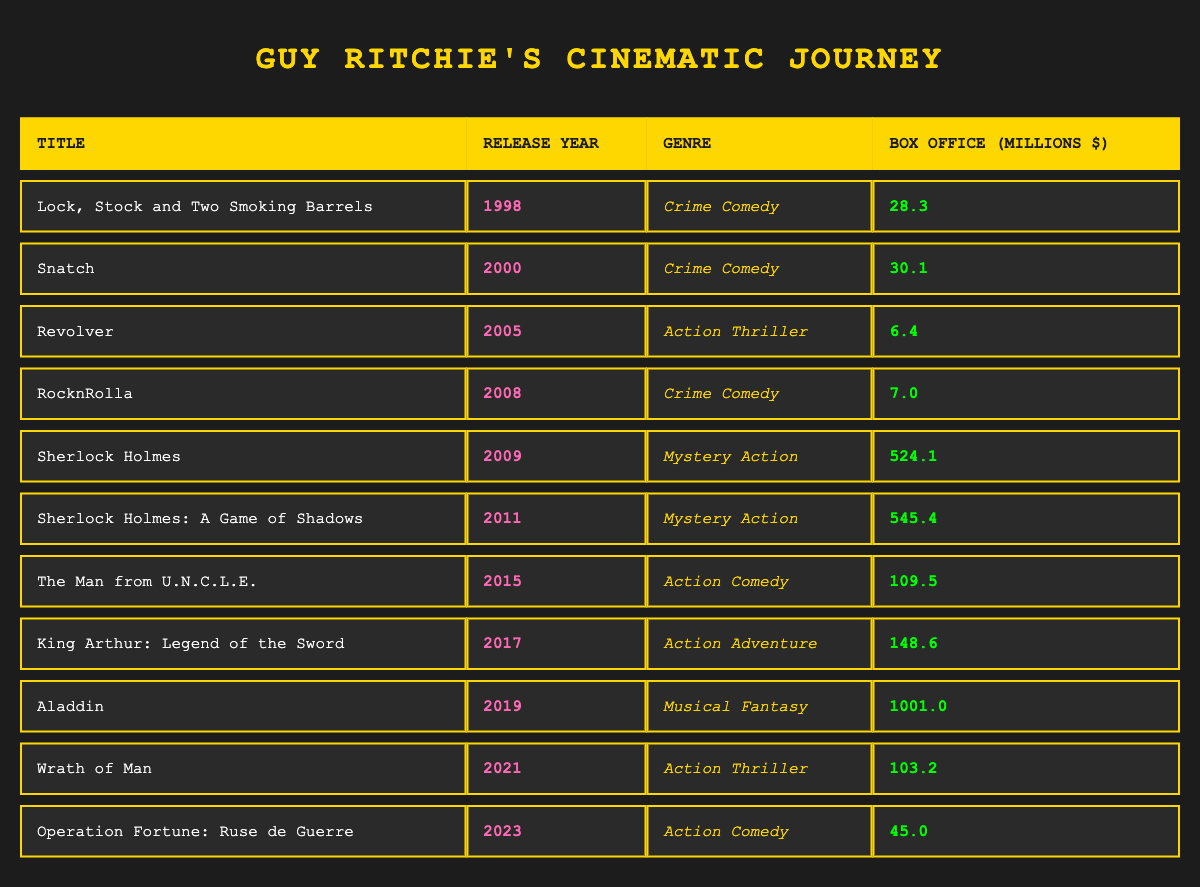What is the box office performance of "Sherlock Holmes"? The table lists "Sherlock Holmes" with a box office performance of 524.1 million dollars, which can be directly read from the box office column for that specific row.
Answer: 524.1 million How many films are classified as "Crime Comedy"? By examining the genre column, there are three films listed under "Crime Comedy": "Lock, Stock and Two Smoking Barrels," "Snatch," and "RocknRolla." Counting these, we find there are three films.
Answer: 3 What is the total box office performance of all the films released after 2015? The films released after 2015 are "Aladdin" (1001.0 million), "Wrath of Man" (103.2 million), and "Operation Fortune: Ruse de Guerre" (45.0 million). Summing these gives 1001.0 + 103.2 + 45.0 = 1149.2 million.
Answer: 1149.2 million Did "Aladdin" outperform all other films in the table in box office revenue? Comparing the box office performances, "Aladdin" has 1001.0 million, which is higher than any other figure listed in the table, including the second highest, "Sherlock Holmes: A Game of Shadows" at 545.4 million. Thus, "Aladdin" did indeed outperform all other films.
Answer: Yes What is the average box office performance of all the "Action Thriller" films? There are three "Action Thriller" films: "Revolver" (6.4 million), "Wrath of Man" (103.2 million). The average is calculated as (6.4 + 103.2) / 2 = 54.8 million.
Answer: 54.8 million Which genre had the highest box office total from its films? The "Mystery Action" genre includes "Sherlock Holmes" (524.1 million) and "Sherlock Holmes: A Game of Shadows" (545.4 million). Their total is 524.1 + 545.4 = 1069.5 million, which is the highest among all genres listed.
Answer: Mystery Action In what year did Guy Ritchie release his least successful film based on box office performance? "Revolver," released in 2005, shows the lowest box office performance at 6.4 million as per the table.
Answer: 2005 How many films exceeded 100 million in box office performance? The films with box office performance over 100 million are "Sherlock Holmes," "Sherlock Holmes: A Game of Shadows," "The Man from U.N.C.L.E.," "King Arthur: Legend of the Sword," and "Aladdin." Counting these gives a total of five films.
Answer: 5 